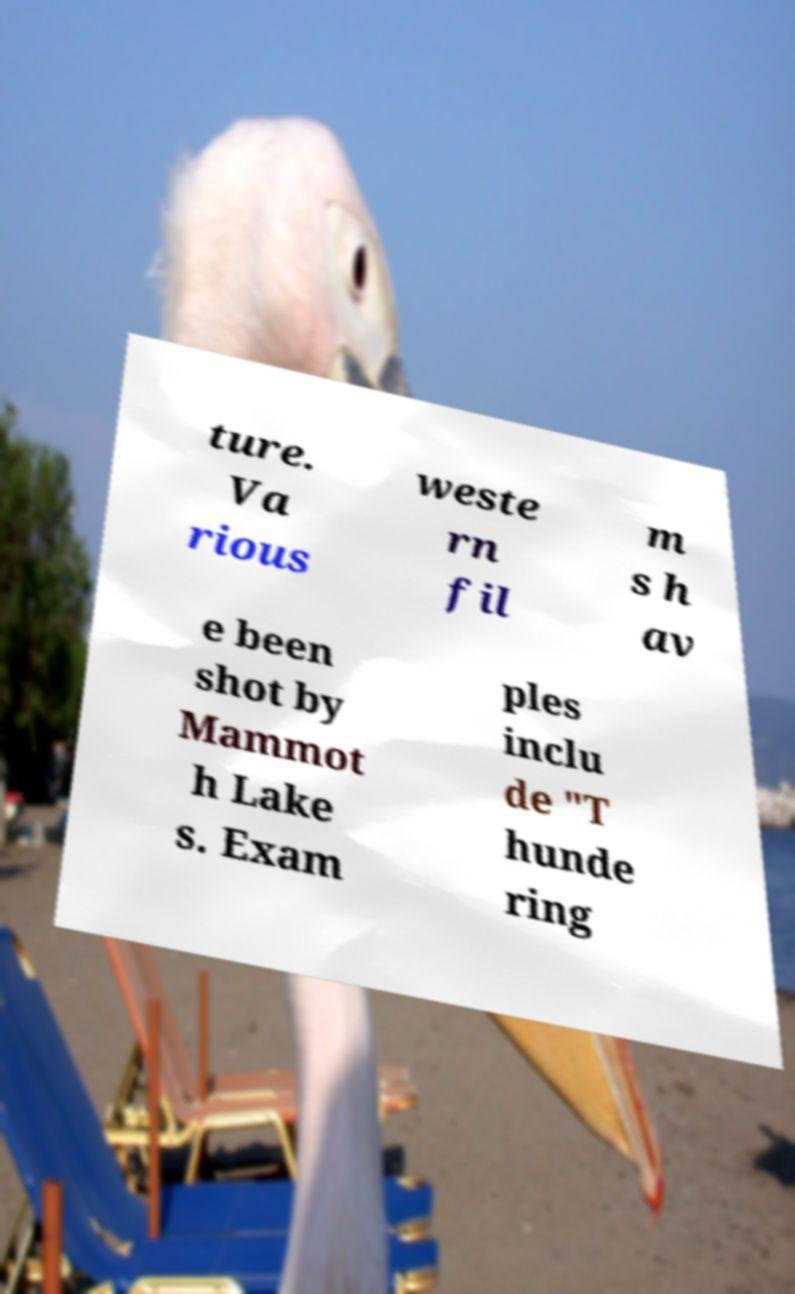Please read and relay the text visible in this image. What does it say? ture. Va rious weste rn fil m s h av e been shot by Mammot h Lake s. Exam ples inclu de "T hunde ring 